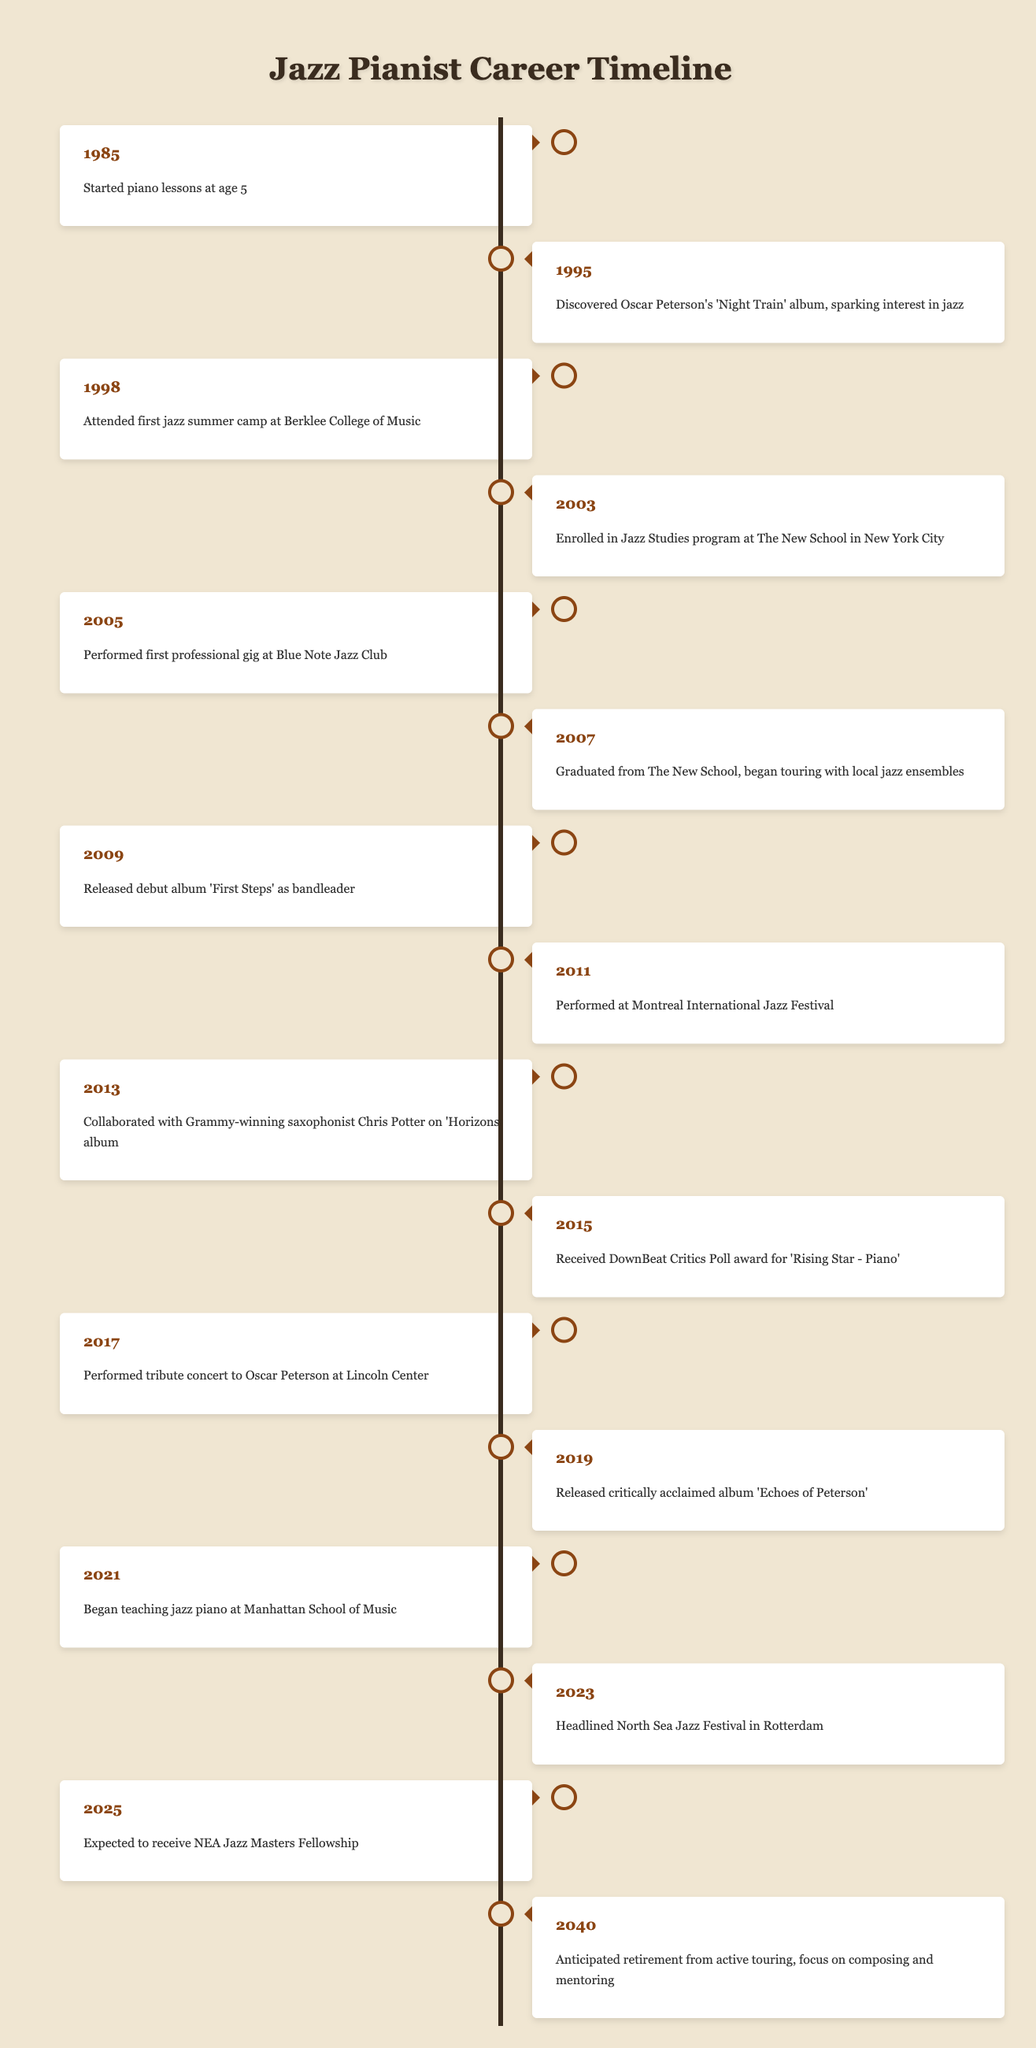What year did the jazz pianist graduate from The New School? The timeline indicates that the pianist graduated from The New School in 2007.
Answer: 2007 What was the first professional gig the jazz pianist performed? The timeline shows that the first professional gig was at the Blue Note Jazz Club in 2005.
Answer: Blue Note Jazz Club Did the jazz pianist release an album in 2019? Yes, the timeline states that the pianist released the critically acclaimed album 'Echoes of Peterson' in 2019.
Answer: Yes In what year was the pianist's first album released, and what was its title? The timeline mentions that the pianist's debut album 'First Steps' was released in 2009.
Answer: 2009, 'First Steps' What milestones focused on Oscar Peterson's influence are listed in the timeline? The timeline references two significant milestones: discovering Oscar Peterson's 'Night Train' album in 1995 and performing a tribute concert to him at Lincoln Center in 2017. Both events show the pianist's connection to Oscar Peterson.
Answer: Discovering 'Night Train' in 1995 and tribute concert in 2017 How many years passed between the jazz pianist's first professional gig and his debut album release? The first professional gig occurred in 2005 and the debut album was released in 2009. The difference is 2009 - 2005 = 4 years.
Answer: 4 years At which prestigious jazz festival did the pianist headline in 2023? The timeline indicates that the pianist headlined the North Sea Jazz Festival in Rotterdam in 2023.
Answer: North Sea Jazz Festival What major achievement is the pianist expected to receive in 2025? The timeline states that the pianist is expected to receive the NEA Jazz Masters Fellowship in 2025, which is a prestigious honor in the jazz community.
Answer: NEA Jazz Masters Fellowship 